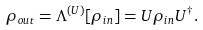Convert formula to latex. <formula><loc_0><loc_0><loc_500><loc_500>\rho _ { o u t } = \Lambda ^ { ( U ) } [ \rho _ { i n } ] = U \rho _ { i n } U ^ { \dagger } .</formula> 